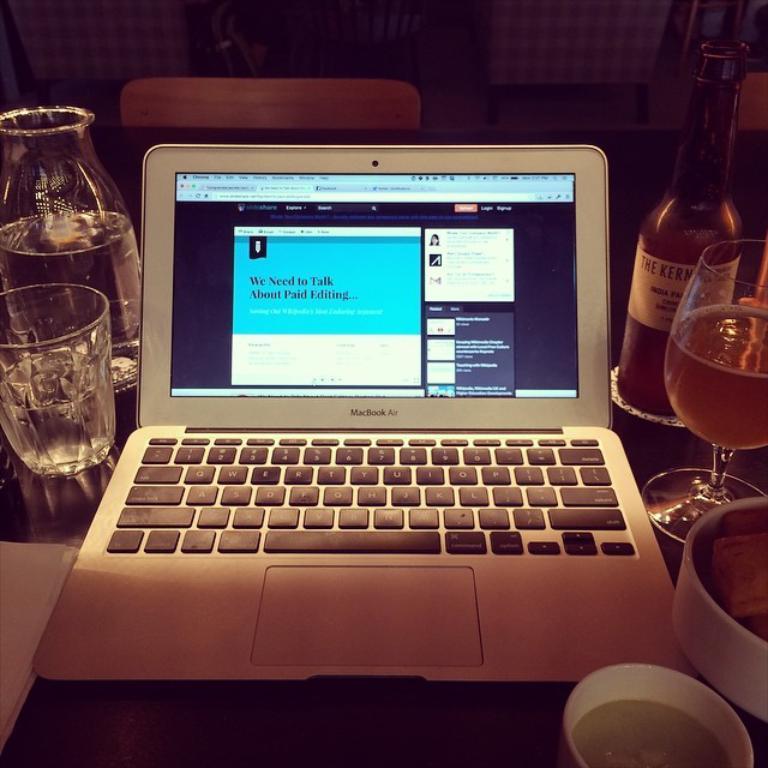Could you give a brief overview of what you see in this image? In this picture I can see there is a laptop and it is placed on a table. There are wine glasses and a wine bottle and in the backdrop there is a chair and a wall. 